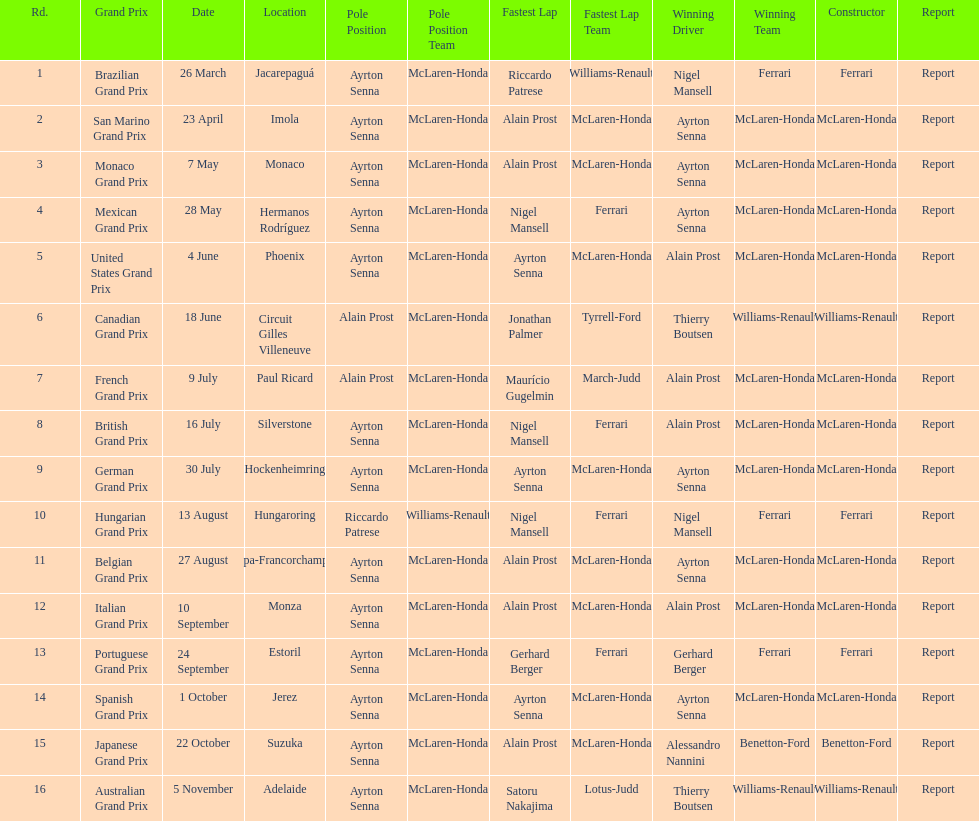How many did alain prost have the fastest lap? 5. 